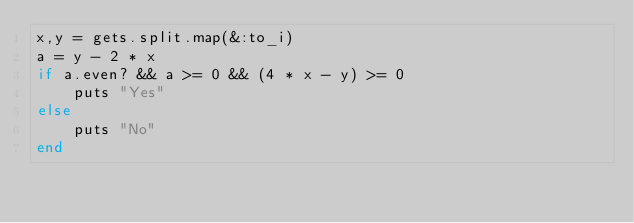<code> <loc_0><loc_0><loc_500><loc_500><_Ruby_>x,y = gets.split.map(&:to_i)
a = y - 2 * x
if a.even? && a >= 0 && (4 * x - y) >= 0
	puts "Yes"
else
	puts "No"
end</code> 